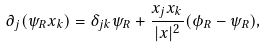Convert formula to latex. <formula><loc_0><loc_0><loc_500><loc_500>\partial _ { j } ( \psi _ { R } x _ { k } ) = \delta _ { j k } \psi _ { R } + \frac { x _ { j } x _ { k } } { | x | ^ { 2 } } ( \phi _ { R } - \psi _ { R } ) ,</formula> 